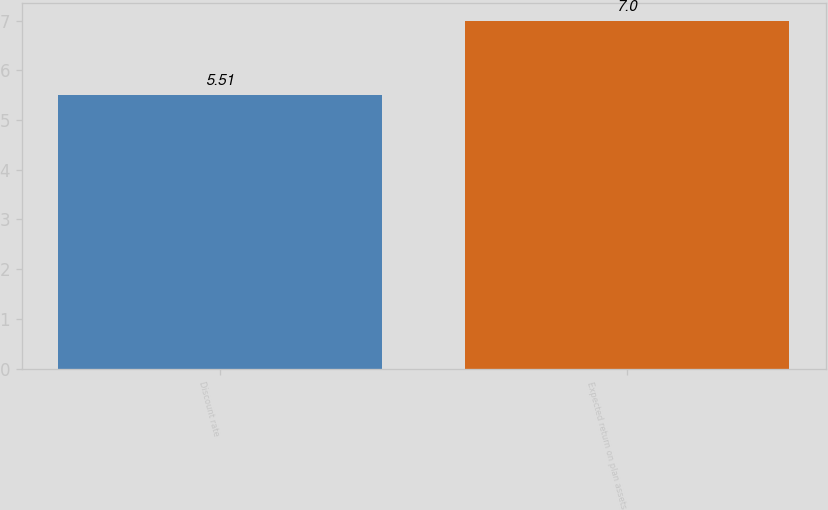Convert chart to OTSL. <chart><loc_0><loc_0><loc_500><loc_500><bar_chart><fcel>Discount rate<fcel>Expected return on plan assets<nl><fcel>5.51<fcel>7<nl></chart> 